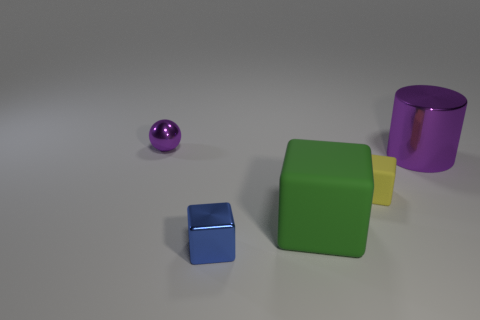How many spheres are the same size as the blue metal block?
Provide a succinct answer. 1. What number of matte things are either small yellow objects or green cubes?
Make the answer very short. 2. What is the big purple cylinder made of?
Keep it short and to the point. Metal. How many shiny things are behind the large green rubber thing?
Offer a terse response. 2. Are the small object that is behind the large purple metal cylinder and the small yellow block made of the same material?
Offer a very short reply. No. How many other matte things are the same shape as the tiny matte thing?
Keep it short and to the point. 1. What number of big objects are purple cylinders or purple shiny objects?
Ensure brevity in your answer.  1. Do the shiny thing right of the blue metallic block and the tiny metal sphere have the same color?
Provide a short and direct response. Yes. Is the color of the tiny metal object that is in front of the ball the same as the matte object that is on the left side of the small rubber thing?
Your response must be concise. No. Are there any gray things made of the same material as the cylinder?
Your answer should be compact. No. 